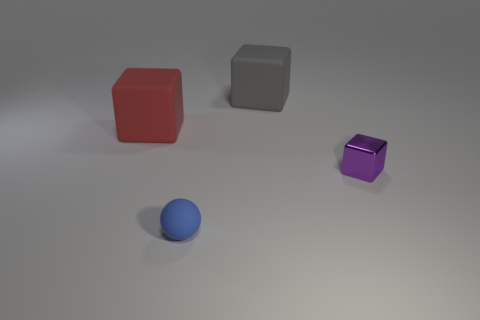Does the matte cube to the left of the gray object have the same size as the purple metal thing? Upon closer examination of the objects in the image, it appears that the matte red cube to the left of the grey object is not the same size as the purple cube. The red cube has larger dimensions compared to the purple cube, which seems smaller in comparison. 